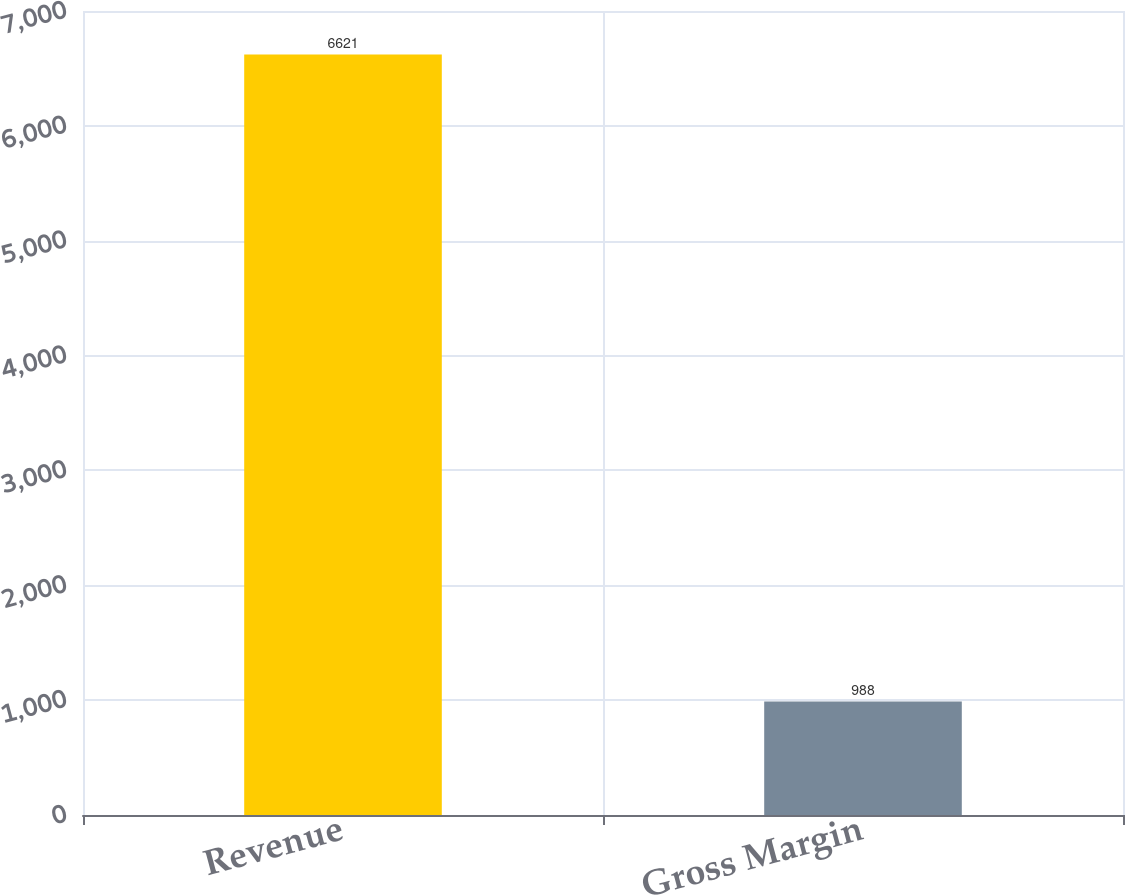Convert chart. <chart><loc_0><loc_0><loc_500><loc_500><bar_chart><fcel>Revenue<fcel>Gross Margin<nl><fcel>6621<fcel>988<nl></chart> 